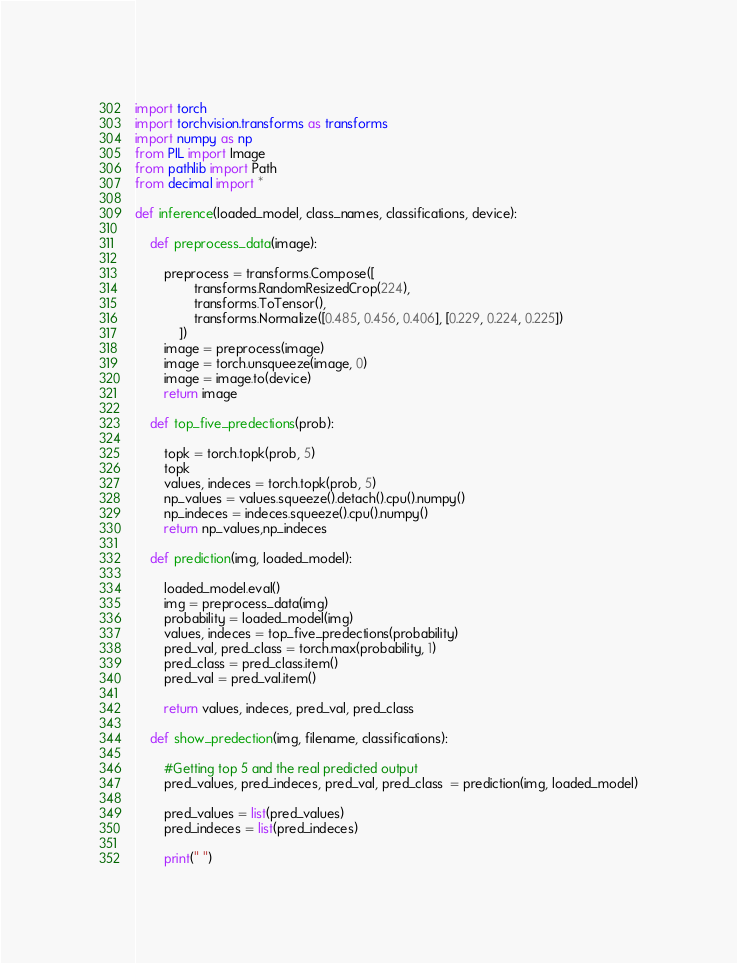<code> <loc_0><loc_0><loc_500><loc_500><_Python_>import torch
import torchvision.transforms as transforms
import numpy as np
from PIL import Image
from pathlib import Path
from decimal import *

def inference(loaded_model, class_names, classifications, device):

    def preprocess_data(image):

        preprocess = transforms.Compose([
                transforms.RandomResizedCrop(224),
                transforms.ToTensor(),
                transforms.Normalize([0.485, 0.456, 0.406], [0.229, 0.224, 0.225])
            ])
        image = preprocess(image)
        image = torch.unsqueeze(image, 0) 
        image = image.to(device)        
        return image

    def top_five_predections(prob):
       
        topk = torch.topk(prob, 5)
        topk
        values, indeces = torch.topk(prob, 5) 
        np_values = values.squeeze().detach().cpu().numpy()
        np_indeces = indeces.squeeze().cpu().numpy()
        return np_values,np_indeces

    def prediction(img, loaded_model):
        
        loaded_model.eval()
        img = preprocess_data(img)
        probability = loaded_model(img) 
        values, indeces = top_five_predections(probability)
        pred_val, pred_class = torch.max(probability, 1)
        pred_class = pred_class.item()
        pred_val = pred_val.item()
        
        return values, indeces, pred_val, pred_class

    def show_predection(img, filename, classifications): 
        
        #Getting top 5 and the real predicted output
        pred_values, pred_indeces, pred_val, pred_class  = prediction(img, loaded_model)

        pred_values = list(pred_values)
        pred_indeces = list(pred_indeces)
                
        print(" ")</code> 